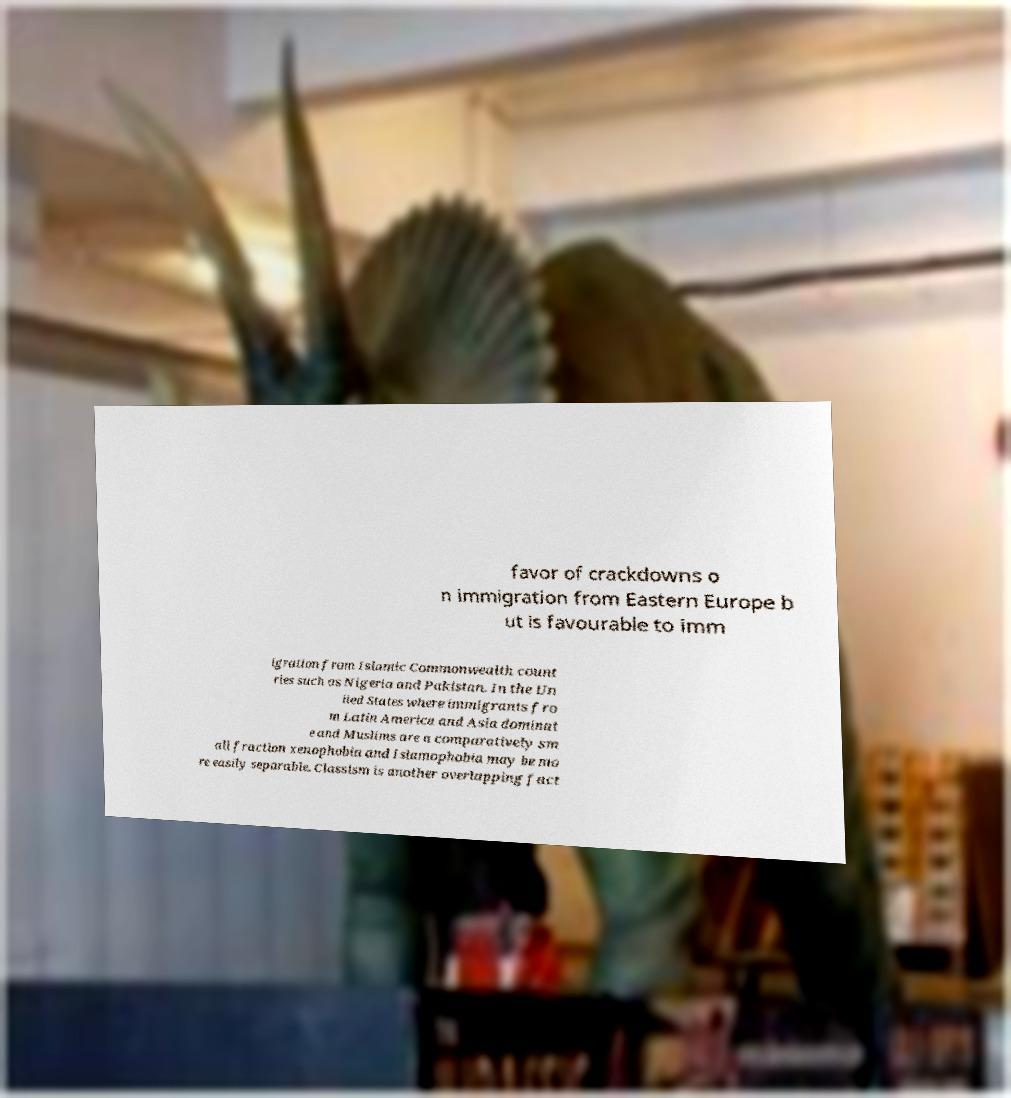For documentation purposes, I need the text within this image transcribed. Could you provide that? favor of crackdowns o n immigration from Eastern Europe b ut is favourable to imm igration from Islamic Commonwealth count ries such as Nigeria and Pakistan. In the Un ited States where immigrants fro m Latin America and Asia dominat e and Muslims are a comparatively sm all fraction xenophobia and Islamophobia may be mo re easily separable. Classism is another overlapping fact 